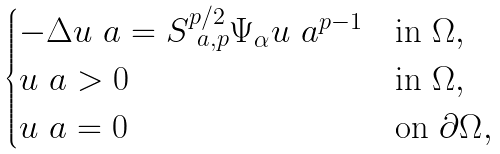Convert formula to latex. <formula><loc_0><loc_0><loc_500><loc_500>\begin{cases} - \Delta u _ { \ } a = S _ { \ a , p } ^ { p / 2 } \Psi _ { \alpha } u _ { \ } a ^ { p - 1 } & \text {in $\Omega$} , \\ u _ { \ } a > 0 & \text {in $\Omega$} , \\ u _ { \ } a = 0 & \text {on $\partial \Omega$} , \end{cases}</formula> 